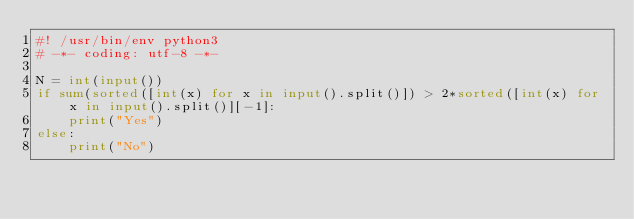Convert code to text. <code><loc_0><loc_0><loc_500><loc_500><_Python_>#! /usr/bin/env python3
# -*- coding: utf-8 -*-

N = int(input())
if sum(sorted([int(x) for x in input().split()]) > 2*sorted([int(x) for x in input().split()][-1]:
    print("Yes")
else:
    print("No")
</code> 